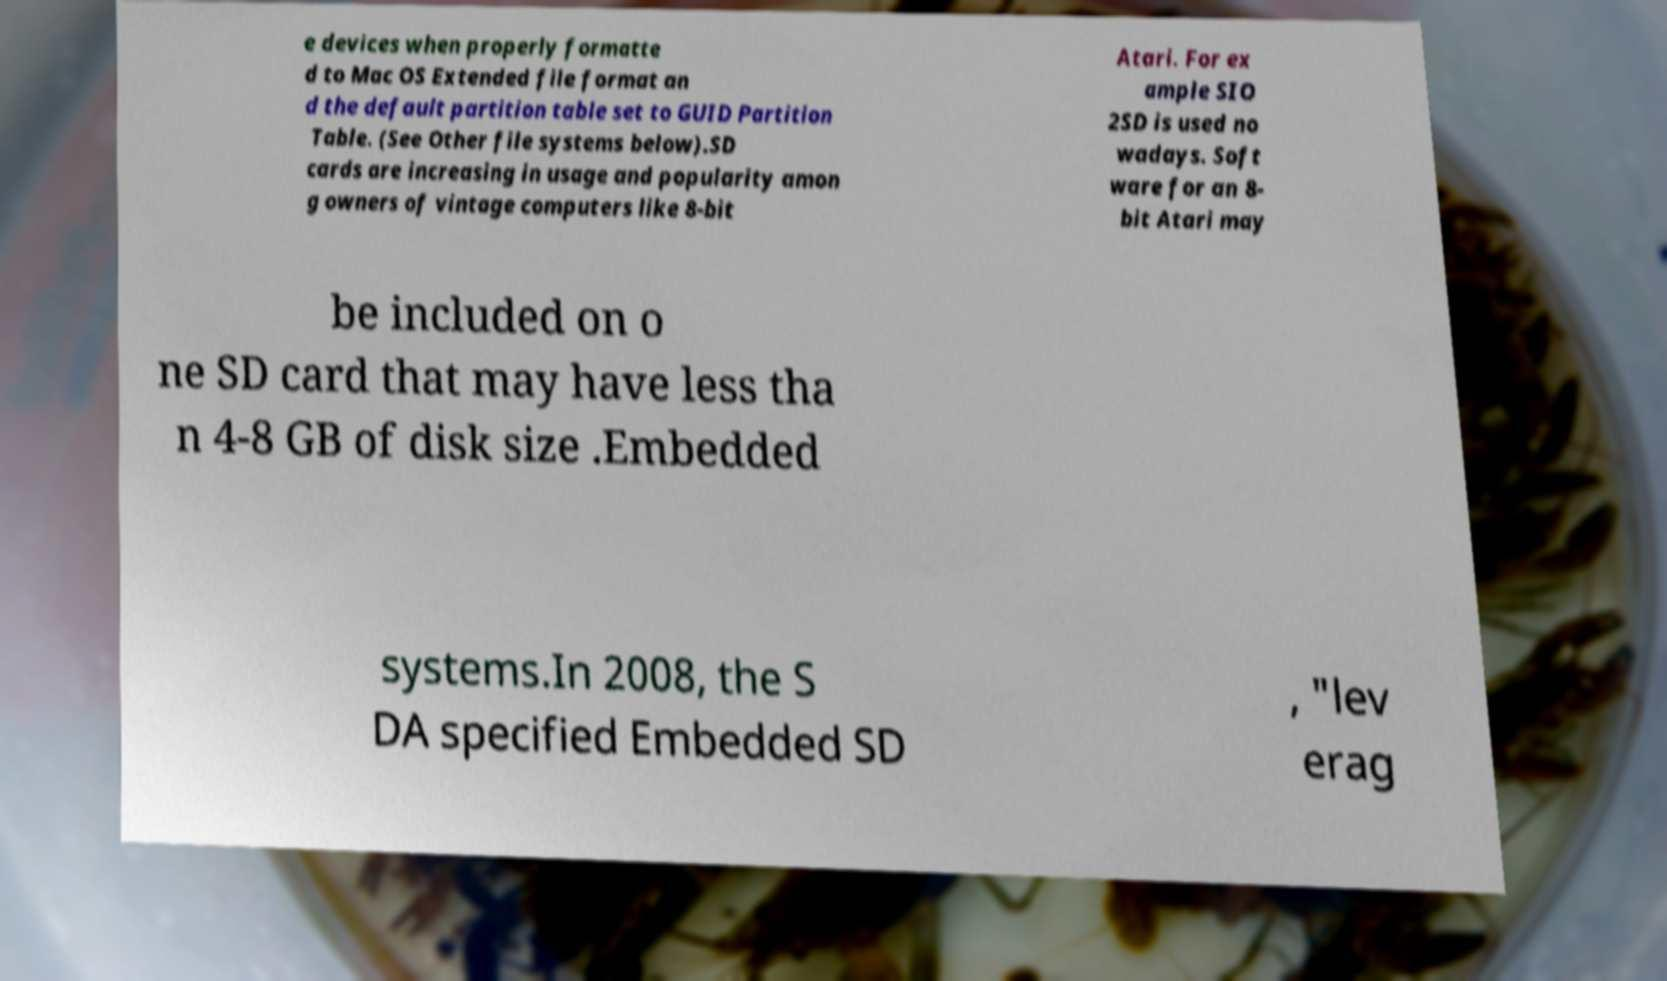Can you read and provide the text displayed in the image?This photo seems to have some interesting text. Can you extract and type it out for me? e devices when properly formatte d to Mac OS Extended file format an d the default partition table set to GUID Partition Table. (See Other file systems below).SD cards are increasing in usage and popularity amon g owners of vintage computers like 8-bit Atari. For ex ample SIO 2SD is used no wadays. Soft ware for an 8- bit Atari may be included on o ne SD card that may have less tha n 4-8 GB of disk size .Embedded systems.In 2008, the S DA specified Embedded SD , "lev erag 